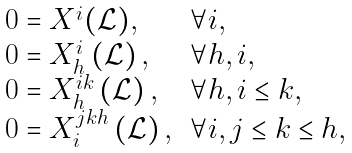<formula> <loc_0><loc_0><loc_500><loc_500>\begin{array} [ c ] { l l } 0 = X ^ { i } ( \mathcal { L } ) , & \forall i , \\ 0 = X _ { h } ^ { i } \left ( \mathcal { L } \right ) , & \forall h , i , \\ 0 = X _ { h } ^ { i k } \left ( \mathcal { L } \right ) , & \forall h , i \leq k , \\ 0 = X _ { i } ^ { j k h } \left ( \mathcal { L } \right ) , & \forall i , j \leq k \leq h , \end{array}</formula> 